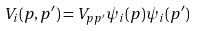Convert formula to latex. <formula><loc_0><loc_0><loc_500><loc_500>V _ { i } ( { p } , { p ^ { \prime } } ) = V _ { p p ^ { \prime } } \psi _ { i } ( { p } ) \psi _ { i } ( { p ^ { \prime } } )</formula> 